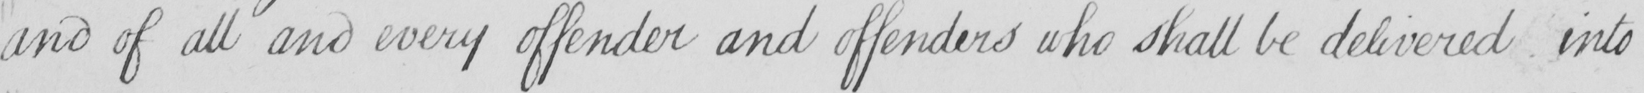Please provide the text content of this handwritten line. and of all and every offender and offenders who shall be delivered into 